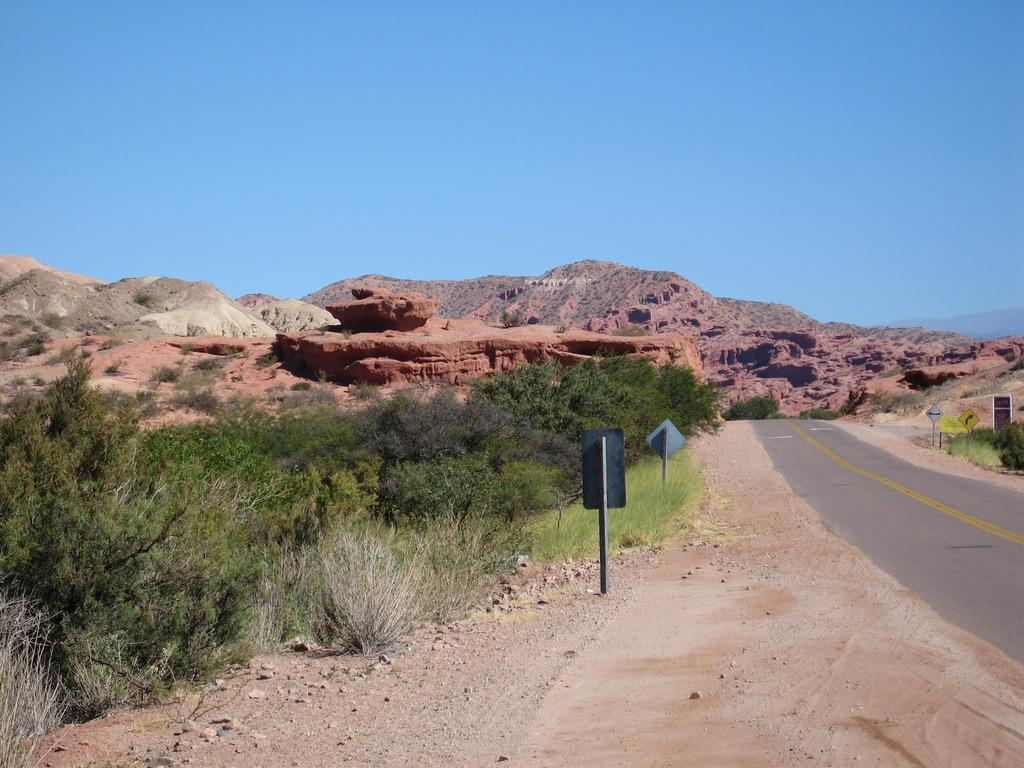What is the main feature of the image? There is a road in the image. What can be seen alongside the road? There are boards along the road. What type of vegetation is present in the image? There are plants and grass in the image. What natural feature is visible in the background? There is a mountain in the image. What is visible in the sky in the image? The sky is visible in the background of the image. How many cats are sitting on the mountain in the image? There are no cats present in the image; it features a road, boards, plants, grass, and a mountain. What type of picture is the horse holding in the image? There is no horse or picture present in the image. 